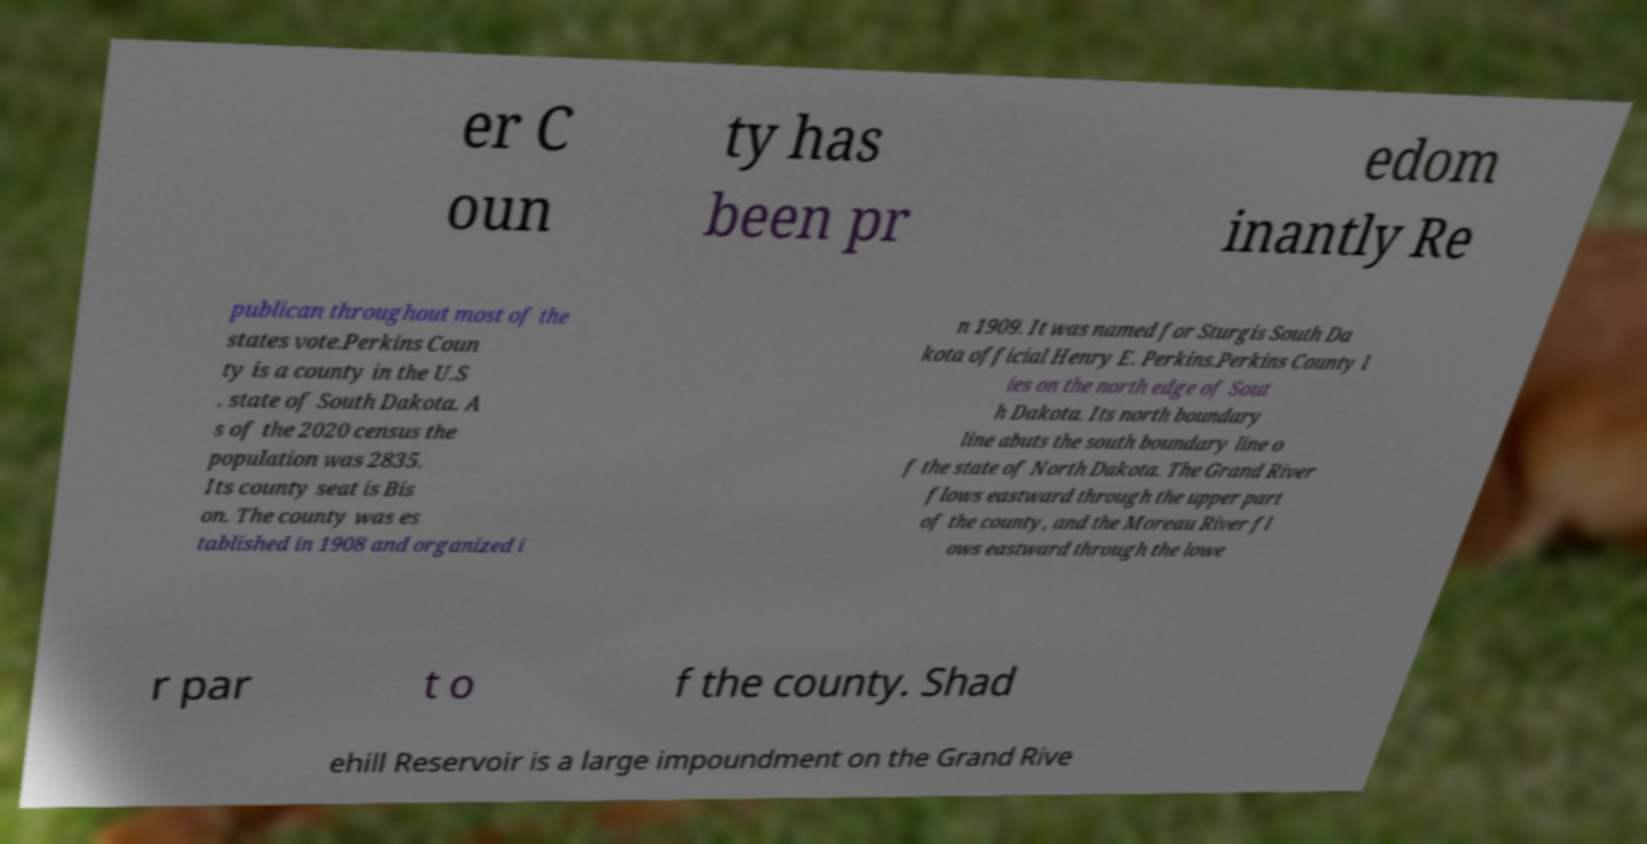Could you assist in decoding the text presented in this image and type it out clearly? er C oun ty has been pr edom inantly Re publican throughout most of the states vote.Perkins Coun ty is a county in the U.S . state of South Dakota. A s of the 2020 census the population was 2835. Its county seat is Bis on. The county was es tablished in 1908 and organized i n 1909. It was named for Sturgis South Da kota official Henry E. Perkins.Perkins County l ies on the north edge of Sout h Dakota. Its north boundary line abuts the south boundary line o f the state of North Dakota. The Grand River flows eastward through the upper part of the county, and the Moreau River fl ows eastward through the lowe r par t o f the county. Shad ehill Reservoir is a large impoundment on the Grand Rive 